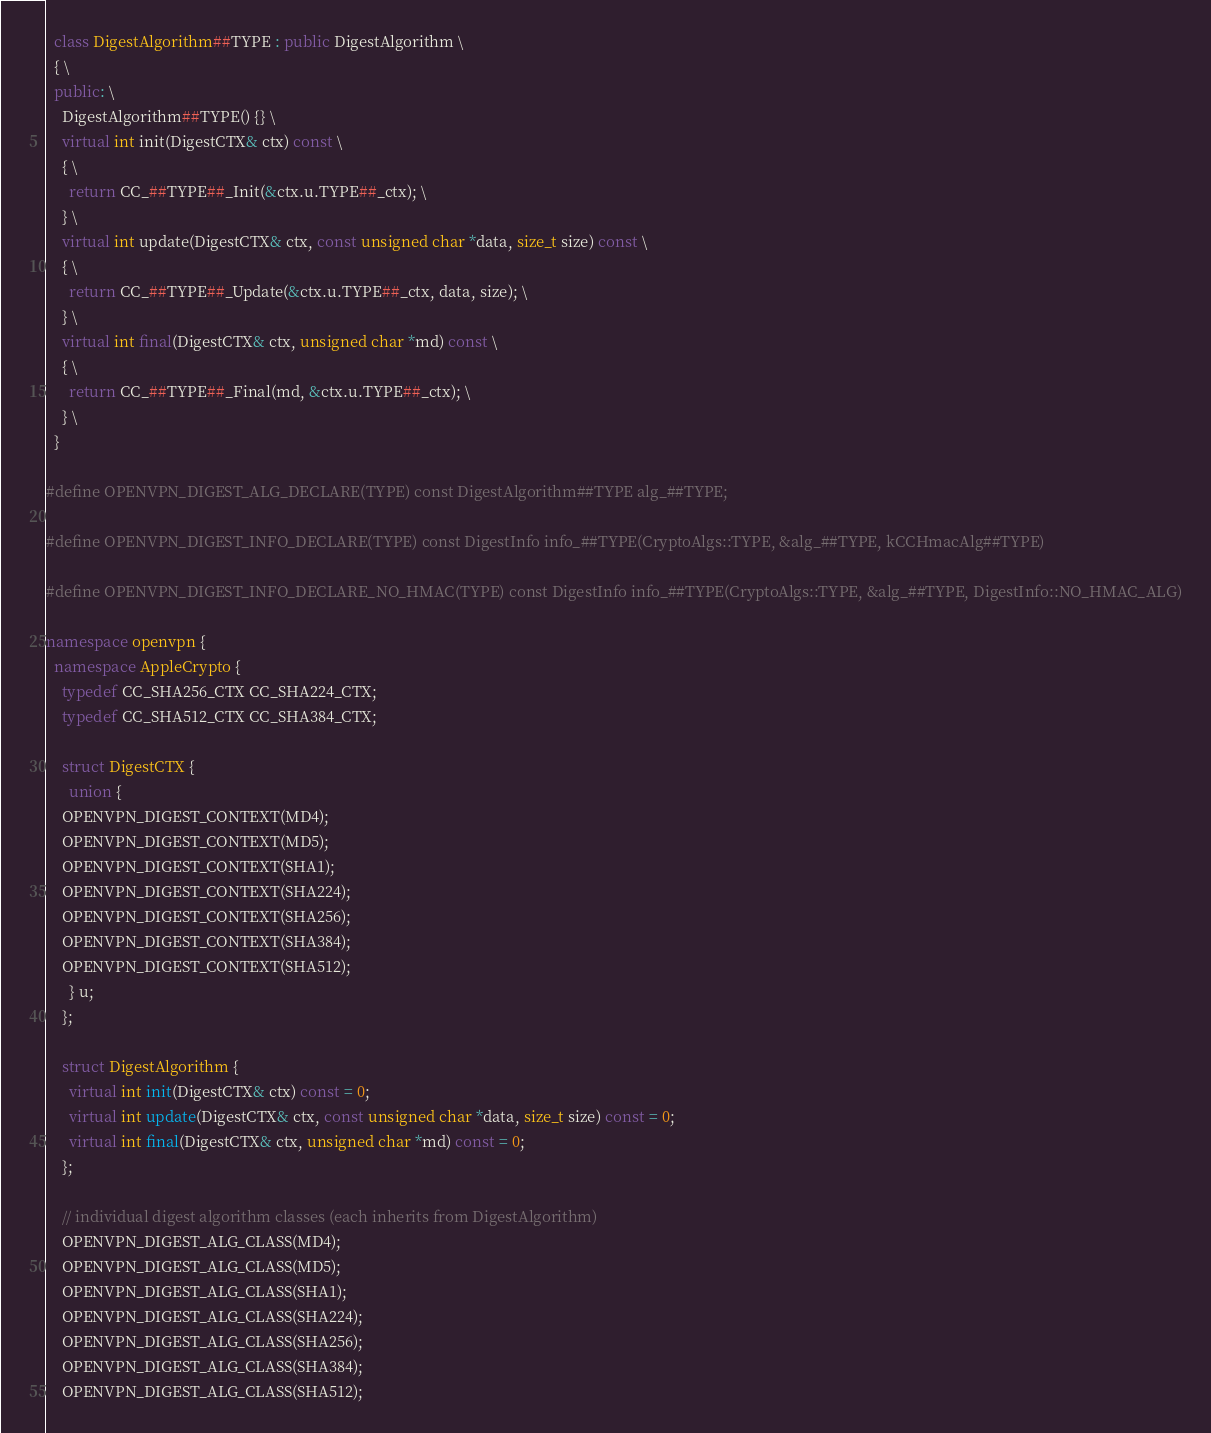<code> <loc_0><loc_0><loc_500><loc_500><_C++_>  class DigestAlgorithm##TYPE : public DigestAlgorithm \
  { \
  public: \
    DigestAlgorithm##TYPE() {} \
    virtual int init(DigestCTX& ctx) const \
    { \
      return CC_##TYPE##_Init(&ctx.u.TYPE##_ctx); \
    } \
    virtual int update(DigestCTX& ctx, const unsigned char *data, size_t size) const \
    { \
      return CC_##TYPE##_Update(&ctx.u.TYPE##_ctx, data, size); \
    } \
    virtual int final(DigestCTX& ctx, unsigned char *md) const \
    { \
      return CC_##TYPE##_Final(md, &ctx.u.TYPE##_ctx); \
    } \
  }

#define OPENVPN_DIGEST_ALG_DECLARE(TYPE) const DigestAlgorithm##TYPE alg_##TYPE;

#define OPENVPN_DIGEST_INFO_DECLARE(TYPE) const DigestInfo info_##TYPE(CryptoAlgs::TYPE, &alg_##TYPE, kCCHmacAlg##TYPE)

#define OPENVPN_DIGEST_INFO_DECLARE_NO_HMAC(TYPE) const DigestInfo info_##TYPE(CryptoAlgs::TYPE, &alg_##TYPE, DigestInfo::NO_HMAC_ALG)

namespace openvpn {
  namespace AppleCrypto {
    typedef CC_SHA256_CTX CC_SHA224_CTX;
    typedef CC_SHA512_CTX CC_SHA384_CTX;

    struct DigestCTX {
      union {
	OPENVPN_DIGEST_CONTEXT(MD4);
	OPENVPN_DIGEST_CONTEXT(MD5);
	OPENVPN_DIGEST_CONTEXT(SHA1);
	OPENVPN_DIGEST_CONTEXT(SHA224);
	OPENVPN_DIGEST_CONTEXT(SHA256);
	OPENVPN_DIGEST_CONTEXT(SHA384);
	OPENVPN_DIGEST_CONTEXT(SHA512);
      } u;
    };

    struct DigestAlgorithm {
      virtual int init(DigestCTX& ctx) const = 0;
      virtual int update(DigestCTX& ctx, const unsigned char *data, size_t size) const = 0;
      virtual int final(DigestCTX& ctx, unsigned char *md) const = 0;
    };

    // individual digest algorithm classes (each inherits from DigestAlgorithm)
    OPENVPN_DIGEST_ALG_CLASS(MD4);
    OPENVPN_DIGEST_ALG_CLASS(MD5);
    OPENVPN_DIGEST_ALG_CLASS(SHA1);
    OPENVPN_DIGEST_ALG_CLASS(SHA224);
    OPENVPN_DIGEST_ALG_CLASS(SHA256);
    OPENVPN_DIGEST_ALG_CLASS(SHA384);
    OPENVPN_DIGEST_ALG_CLASS(SHA512);
</code> 